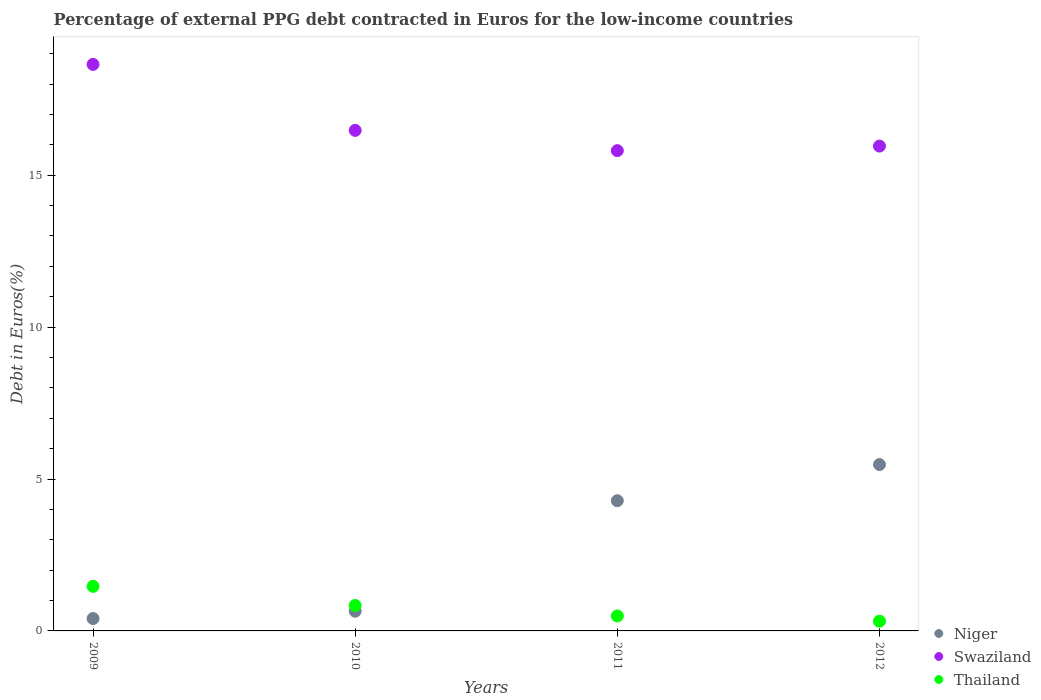How many different coloured dotlines are there?
Offer a very short reply. 3. Is the number of dotlines equal to the number of legend labels?
Give a very brief answer. Yes. What is the percentage of external PPG debt contracted in Euros in Thailand in 2012?
Provide a succinct answer. 0.32. Across all years, what is the maximum percentage of external PPG debt contracted in Euros in Swaziland?
Provide a short and direct response. 18.64. Across all years, what is the minimum percentage of external PPG debt contracted in Euros in Swaziland?
Ensure brevity in your answer.  15.81. In which year was the percentage of external PPG debt contracted in Euros in Niger minimum?
Make the answer very short. 2009. What is the total percentage of external PPG debt contracted in Euros in Thailand in the graph?
Give a very brief answer. 3.12. What is the difference between the percentage of external PPG debt contracted in Euros in Thailand in 2009 and that in 2010?
Give a very brief answer. 0.63. What is the difference between the percentage of external PPG debt contracted in Euros in Swaziland in 2012 and the percentage of external PPG debt contracted in Euros in Niger in 2009?
Your answer should be compact. 15.55. What is the average percentage of external PPG debt contracted in Euros in Niger per year?
Provide a succinct answer. 2.7. In the year 2012, what is the difference between the percentage of external PPG debt contracted in Euros in Thailand and percentage of external PPG debt contracted in Euros in Swaziland?
Offer a terse response. -15.64. In how many years, is the percentage of external PPG debt contracted in Euros in Swaziland greater than 6 %?
Provide a short and direct response. 4. What is the ratio of the percentage of external PPG debt contracted in Euros in Niger in 2011 to that in 2012?
Give a very brief answer. 0.78. Is the percentage of external PPG debt contracted in Euros in Thailand in 2009 less than that in 2012?
Keep it short and to the point. No. Is the difference between the percentage of external PPG debt contracted in Euros in Thailand in 2010 and 2012 greater than the difference between the percentage of external PPG debt contracted in Euros in Swaziland in 2010 and 2012?
Your answer should be very brief. Yes. What is the difference between the highest and the second highest percentage of external PPG debt contracted in Euros in Swaziland?
Give a very brief answer. 2.17. What is the difference between the highest and the lowest percentage of external PPG debt contracted in Euros in Thailand?
Offer a very short reply. 1.15. Does the percentage of external PPG debt contracted in Euros in Thailand monotonically increase over the years?
Provide a short and direct response. No. Is the percentage of external PPG debt contracted in Euros in Niger strictly less than the percentage of external PPG debt contracted in Euros in Thailand over the years?
Make the answer very short. No. How many dotlines are there?
Ensure brevity in your answer.  3. Are the values on the major ticks of Y-axis written in scientific E-notation?
Your answer should be compact. No. Does the graph contain any zero values?
Your answer should be compact. No. What is the title of the graph?
Provide a succinct answer. Percentage of external PPG debt contracted in Euros for the low-income countries. Does "Vietnam" appear as one of the legend labels in the graph?
Offer a terse response. No. What is the label or title of the X-axis?
Keep it short and to the point. Years. What is the label or title of the Y-axis?
Your response must be concise. Debt in Euros(%). What is the Debt in Euros(%) in Niger in 2009?
Give a very brief answer. 0.41. What is the Debt in Euros(%) of Swaziland in 2009?
Offer a very short reply. 18.64. What is the Debt in Euros(%) of Thailand in 2009?
Your response must be concise. 1.47. What is the Debt in Euros(%) of Niger in 2010?
Your answer should be compact. 0.65. What is the Debt in Euros(%) in Swaziland in 2010?
Your answer should be very brief. 16.47. What is the Debt in Euros(%) in Thailand in 2010?
Provide a short and direct response. 0.84. What is the Debt in Euros(%) in Niger in 2011?
Your answer should be very brief. 4.29. What is the Debt in Euros(%) of Swaziland in 2011?
Your answer should be very brief. 15.81. What is the Debt in Euros(%) of Thailand in 2011?
Keep it short and to the point. 0.49. What is the Debt in Euros(%) in Niger in 2012?
Your answer should be compact. 5.48. What is the Debt in Euros(%) of Swaziland in 2012?
Your answer should be very brief. 15.96. What is the Debt in Euros(%) of Thailand in 2012?
Your answer should be compact. 0.32. Across all years, what is the maximum Debt in Euros(%) of Niger?
Provide a succinct answer. 5.48. Across all years, what is the maximum Debt in Euros(%) in Swaziland?
Give a very brief answer. 18.64. Across all years, what is the maximum Debt in Euros(%) in Thailand?
Your response must be concise. 1.47. Across all years, what is the minimum Debt in Euros(%) of Niger?
Provide a short and direct response. 0.41. Across all years, what is the minimum Debt in Euros(%) in Swaziland?
Your answer should be compact. 15.81. Across all years, what is the minimum Debt in Euros(%) in Thailand?
Your response must be concise. 0.32. What is the total Debt in Euros(%) in Niger in the graph?
Offer a terse response. 10.82. What is the total Debt in Euros(%) of Swaziland in the graph?
Provide a short and direct response. 66.88. What is the total Debt in Euros(%) of Thailand in the graph?
Make the answer very short. 3.12. What is the difference between the Debt in Euros(%) in Niger in 2009 and that in 2010?
Your answer should be compact. -0.24. What is the difference between the Debt in Euros(%) of Swaziland in 2009 and that in 2010?
Keep it short and to the point. 2.17. What is the difference between the Debt in Euros(%) in Thailand in 2009 and that in 2010?
Provide a succinct answer. 0.63. What is the difference between the Debt in Euros(%) in Niger in 2009 and that in 2011?
Provide a succinct answer. -3.88. What is the difference between the Debt in Euros(%) of Swaziland in 2009 and that in 2011?
Your answer should be compact. 2.84. What is the difference between the Debt in Euros(%) of Thailand in 2009 and that in 2011?
Your answer should be compact. 0.97. What is the difference between the Debt in Euros(%) of Niger in 2009 and that in 2012?
Keep it short and to the point. -5.07. What is the difference between the Debt in Euros(%) in Swaziland in 2009 and that in 2012?
Your answer should be compact. 2.69. What is the difference between the Debt in Euros(%) in Thailand in 2009 and that in 2012?
Your answer should be very brief. 1.15. What is the difference between the Debt in Euros(%) in Niger in 2010 and that in 2011?
Your answer should be compact. -3.64. What is the difference between the Debt in Euros(%) of Swaziland in 2010 and that in 2011?
Make the answer very short. 0.67. What is the difference between the Debt in Euros(%) of Thailand in 2010 and that in 2011?
Offer a terse response. 0.34. What is the difference between the Debt in Euros(%) in Niger in 2010 and that in 2012?
Provide a succinct answer. -4.83. What is the difference between the Debt in Euros(%) in Swaziland in 2010 and that in 2012?
Provide a short and direct response. 0.52. What is the difference between the Debt in Euros(%) in Thailand in 2010 and that in 2012?
Provide a succinct answer. 0.52. What is the difference between the Debt in Euros(%) of Niger in 2011 and that in 2012?
Offer a very short reply. -1.19. What is the difference between the Debt in Euros(%) in Swaziland in 2011 and that in 2012?
Keep it short and to the point. -0.15. What is the difference between the Debt in Euros(%) in Thailand in 2011 and that in 2012?
Give a very brief answer. 0.17. What is the difference between the Debt in Euros(%) in Niger in 2009 and the Debt in Euros(%) in Swaziland in 2010?
Keep it short and to the point. -16.07. What is the difference between the Debt in Euros(%) in Niger in 2009 and the Debt in Euros(%) in Thailand in 2010?
Your response must be concise. -0.43. What is the difference between the Debt in Euros(%) of Swaziland in 2009 and the Debt in Euros(%) of Thailand in 2010?
Your response must be concise. 17.81. What is the difference between the Debt in Euros(%) in Niger in 2009 and the Debt in Euros(%) in Swaziland in 2011?
Provide a short and direct response. -15.4. What is the difference between the Debt in Euros(%) in Niger in 2009 and the Debt in Euros(%) in Thailand in 2011?
Offer a very short reply. -0.09. What is the difference between the Debt in Euros(%) in Swaziland in 2009 and the Debt in Euros(%) in Thailand in 2011?
Your answer should be compact. 18.15. What is the difference between the Debt in Euros(%) of Niger in 2009 and the Debt in Euros(%) of Swaziland in 2012?
Make the answer very short. -15.55. What is the difference between the Debt in Euros(%) of Niger in 2009 and the Debt in Euros(%) of Thailand in 2012?
Offer a terse response. 0.09. What is the difference between the Debt in Euros(%) of Swaziland in 2009 and the Debt in Euros(%) of Thailand in 2012?
Provide a succinct answer. 18.33. What is the difference between the Debt in Euros(%) in Niger in 2010 and the Debt in Euros(%) in Swaziland in 2011?
Your response must be concise. -15.16. What is the difference between the Debt in Euros(%) in Niger in 2010 and the Debt in Euros(%) in Thailand in 2011?
Your answer should be compact. 0.16. What is the difference between the Debt in Euros(%) of Swaziland in 2010 and the Debt in Euros(%) of Thailand in 2011?
Your response must be concise. 15.98. What is the difference between the Debt in Euros(%) of Niger in 2010 and the Debt in Euros(%) of Swaziland in 2012?
Your answer should be compact. -15.31. What is the difference between the Debt in Euros(%) in Niger in 2010 and the Debt in Euros(%) in Thailand in 2012?
Keep it short and to the point. 0.33. What is the difference between the Debt in Euros(%) of Swaziland in 2010 and the Debt in Euros(%) of Thailand in 2012?
Provide a short and direct response. 16.15. What is the difference between the Debt in Euros(%) of Niger in 2011 and the Debt in Euros(%) of Swaziland in 2012?
Provide a succinct answer. -11.67. What is the difference between the Debt in Euros(%) of Niger in 2011 and the Debt in Euros(%) of Thailand in 2012?
Offer a very short reply. 3.97. What is the difference between the Debt in Euros(%) of Swaziland in 2011 and the Debt in Euros(%) of Thailand in 2012?
Your response must be concise. 15.49. What is the average Debt in Euros(%) of Niger per year?
Ensure brevity in your answer.  2.7. What is the average Debt in Euros(%) in Swaziland per year?
Your answer should be very brief. 16.72. What is the average Debt in Euros(%) in Thailand per year?
Give a very brief answer. 0.78. In the year 2009, what is the difference between the Debt in Euros(%) of Niger and Debt in Euros(%) of Swaziland?
Provide a succinct answer. -18.24. In the year 2009, what is the difference between the Debt in Euros(%) of Niger and Debt in Euros(%) of Thailand?
Keep it short and to the point. -1.06. In the year 2009, what is the difference between the Debt in Euros(%) in Swaziland and Debt in Euros(%) in Thailand?
Your answer should be compact. 17.18. In the year 2010, what is the difference between the Debt in Euros(%) of Niger and Debt in Euros(%) of Swaziland?
Your response must be concise. -15.82. In the year 2010, what is the difference between the Debt in Euros(%) of Niger and Debt in Euros(%) of Thailand?
Offer a terse response. -0.19. In the year 2010, what is the difference between the Debt in Euros(%) in Swaziland and Debt in Euros(%) in Thailand?
Ensure brevity in your answer.  15.64. In the year 2011, what is the difference between the Debt in Euros(%) in Niger and Debt in Euros(%) in Swaziland?
Make the answer very short. -11.52. In the year 2011, what is the difference between the Debt in Euros(%) of Niger and Debt in Euros(%) of Thailand?
Give a very brief answer. 3.79. In the year 2011, what is the difference between the Debt in Euros(%) of Swaziland and Debt in Euros(%) of Thailand?
Offer a terse response. 15.31. In the year 2012, what is the difference between the Debt in Euros(%) in Niger and Debt in Euros(%) in Swaziland?
Your response must be concise. -10.48. In the year 2012, what is the difference between the Debt in Euros(%) of Niger and Debt in Euros(%) of Thailand?
Your answer should be compact. 5.16. In the year 2012, what is the difference between the Debt in Euros(%) of Swaziland and Debt in Euros(%) of Thailand?
Your answer should be very brief. 15.64. What is the ratio of the Debt in Euros(%) of Niger in 2009 to that in 2010?
Give a very brief answer. 0.63. What is the ratio of the Debt in Euros(%) in Swaziland in 2009 to that in 2010?
Offer a very short reply. 1.13. What is the ratio of the Debt in Euros(%) in Thailand in 2009 to that in 2010?
Give a very brief answer. 1.75. What is the ratio of the Debt in Euros(%) in Niger in 2009 to that in 2011?
Keep it short and to the point. 0.1. What is the ratio of the Debt in Euros(%) in Swaziland in 2009 to that in 2011?
Provide a short and direct response. 1.18. What is the ratio of the Debt in Euros(%) of Thailand in 2009 to that in 2011?
Your answer should be very brief. 2.98. What is the ratio of the Debt in Euros(%) of Niger in 2009 to that in 2012?
Provide a short and direct response. 0.07. What is the ratio of the Debt in Euros(%) of Swaziland in 2009 to that in 2012?
Your answer should be very brief. 1.17. What is the ratio of the Debt in Euros(%) in Thailand in 2009 to that in 2012?
Provide a short and direct response. 4.59. What is the ratio of the Debt in Euros(%) of Niger in 2010 to that in 2011?
Offer a very short reply. 0.15. What is the ratio of the Debt in Euros(%) of Swaziland in 2010 to that in 2011?
Provide a short and direct response. 1.04. What is the ratio of the Debt in Euros(%) of Thailand in 2010 to that in 2011?
Your answer should be compact. 1.7. What is the ratio of the Debt in Euros(%) of Niger in 2010 to that in 2012?
Your response must be concise. 0.12. What is the ratio of the Debt in Euros(%) in Swaziland in 2010 to that in 2012?
Provide a short and direct response. 1.03. What is the ratio of the Debt in Euros(%) of Thailand in 2010 to that in 2012?
Keep it short and to the point. 2.62. What is the ratio of the Debt in Euros(%) in Niger in 2011 to that in 2012?
Provide a short and direct response. 0.78. What is the ratio of the Debt in Euros(%) of Swaziland in 2011 to that in 2012?
Make the answer very short. 0.99. What is the ratio of the Debt in Euros(%) of Thailand in 2011 to that in 2012?
Give a very brief answer. 1.54. What is the difference between the highest and the second highest Debt in Euros(%) of Niger?
Your answer should be very brief. 1.19. What is the difference between the highest and the second highest Debt in Euros(%) of Swaziland?
Offer a very short reply. 2.17. What is the difference between the highest and the second highest Debt in Euros(%) of Thailand?
Offer a terse response. 0.63. What is the difference between the highest and the lowest Debt in Euros(%) in Niger?
Make the answer very short. 5.07. What is the difference between the highest and the lowest Debt in Euros(%) in Swaziland?
Offer a terse response. 2.84. What is the difference between the highest and the lowest Debt in Euros(%) in Thailand?
Offer a very short reply. 1.15. 